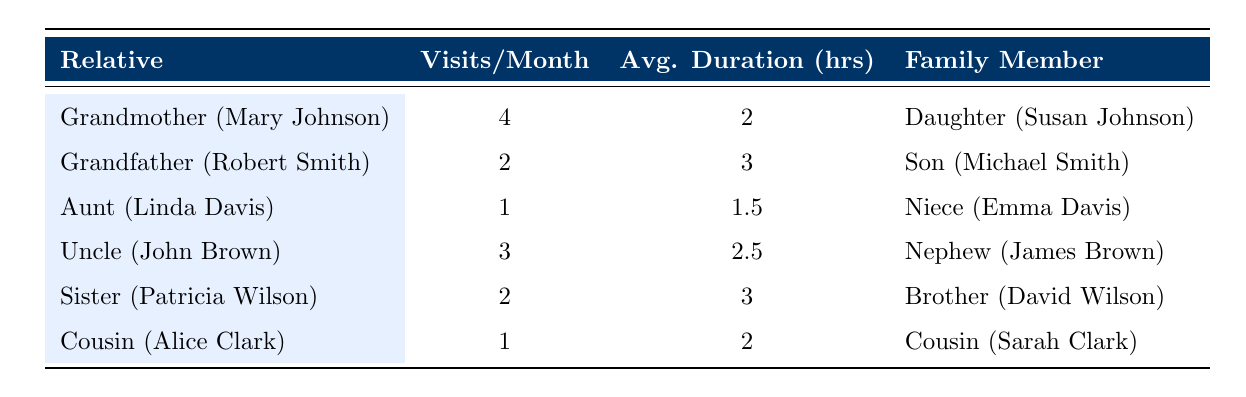What is the visit frequency per month for the Grandmother? The table states that the visit frequency per month for Grandmother (Mary Johnson) is 4.
Answer: 4 Who visits the Uncle (John Brown)? According to the table, the family member that visits Uncle (John Brown) is Nephew (James Brown).
Answer: Nephew (James Brown) What is the average visit duration for the Aunt (Linda Davis)? The table shows that the average visit duration for Aunt (Linda Davis) is 1.5 hours.
Answer: 1.5 hours How many relatives receive more than 2 visits per month? Upon reviewing the table, we see that Grandmother (Mary Johnson) and Uncle (John Brown) have more than 2 visits per month, totaling 2 relatives.
Answer: 2 relatives What is the total frequency of visits per month for all relatives combined? To find the total frequency, we add the visits: 4 (Grandmother) + 2 (Grandfather) + 1 (Aunt) + 3 (Uncle) + 2 (Sister) + 1 (Cousin) = 13 visits per month total.
Answer: 13 visits Is the average visit duration for the Grandfather greater than 2 hours? The table indicates that the average visit duration for Grandfather (Robert Smith) is 3 hours, which is indeed greater than 2 hours.
Answer: Yes Who has the least frequency of visits, and how many visits do they make per month? The table shows that Aunt (Linda Davis) and Cousin (Alice Clark) both have a visit frequency of 1, making them the least frequent visitors.
Answer: Aunt (Linda Davis) and Cousin (Alice Clark), 1 visit What is the average frequency of visits for all family members? To find the average frequency, we calculate the total visits (13 from the previous question) and divide it by the number of relatives (6): 13/6 = 2.17 visits per month on average.
Answer: 2.17 visits per month Which family member has the longest average visit duration? Analyzing the average visit durations, Grandfather (3 hours) has the longest average visit duration compared to the others listed.
Answer: Grandfather (Robert Smith) 